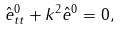Convert formula to latex. <formula><loc_0><loc_0><loc_500><loc_500>\hat { e } _ { t t } ^ { 0 } + k ^ { 2 } \hat { e } ^ { 0 } = 0 ,</formula> 